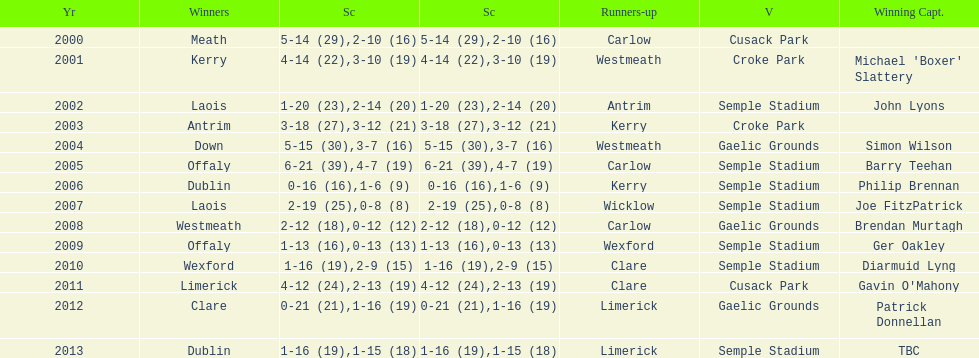Who was the winning captain the last time the competition was held at the gaelic grounds venue? Patrick Donnellan. 